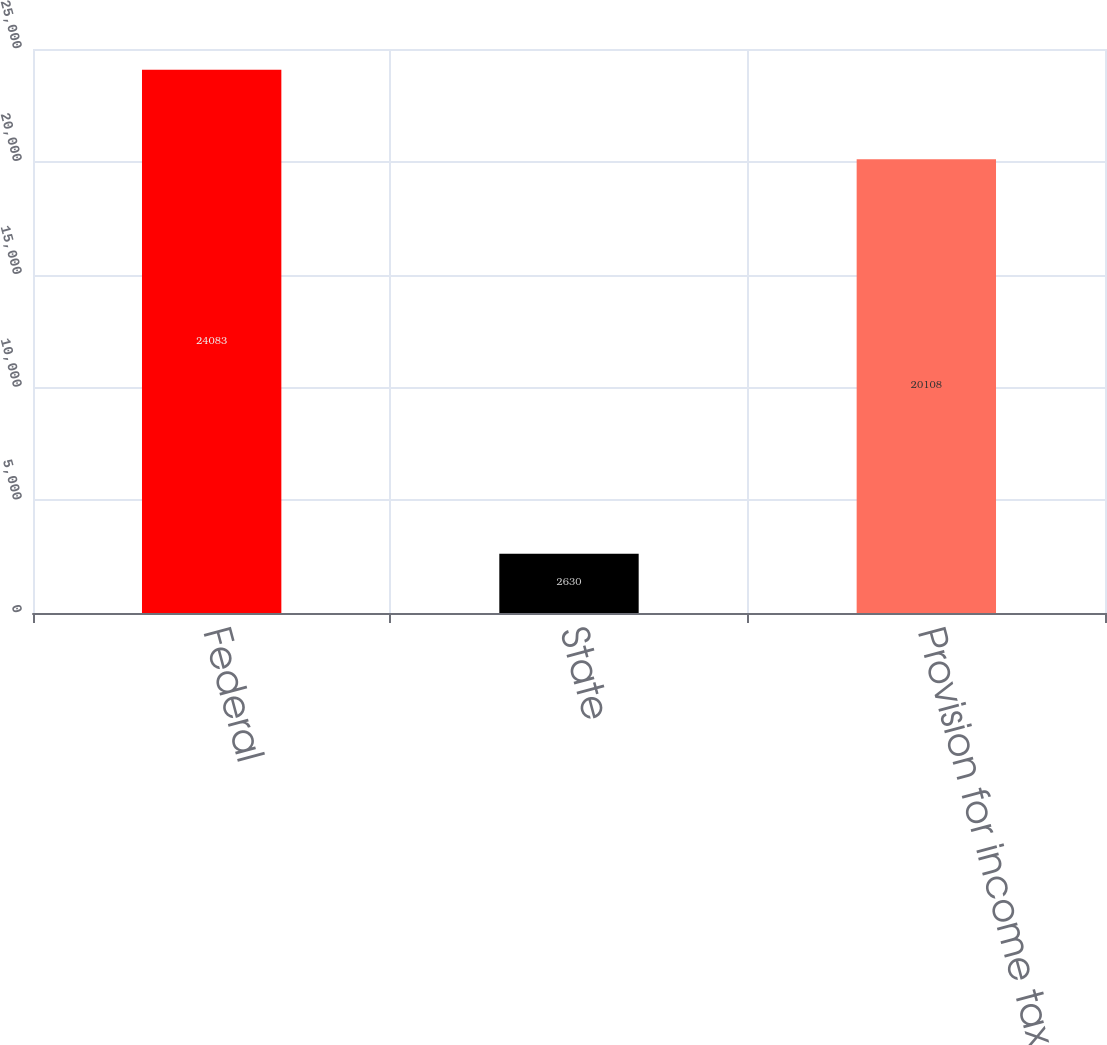<chart> <loc_0><loc_0><loc_500><loc_500><bar_chart><fcel>Federal<fcel>State<fcel>Provision for income taxes<nl><fcel>24083<fcel>2630<fcel>20108<nl></chart> 